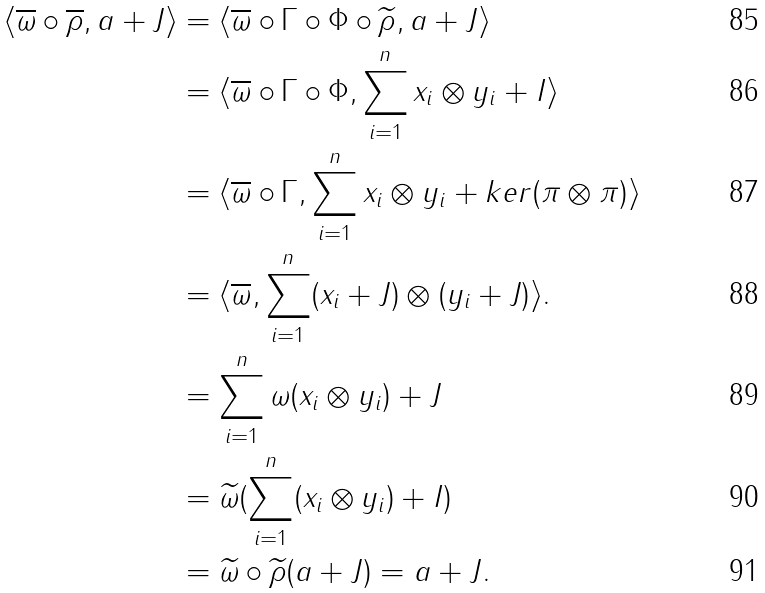Convert formula to latex. <formula><loc_0><loc_0><loc_500><loc_500>\langle \overline { \omega } \circ \overline { \rho } , a + J \rangle & = \langle \overline { \omega } \circ \Gamma \circ \Phi \circ \widetilde { \rho } , a + J \rangle \\ & = \langle \overline { \omega } \circ \Gamma \circ \Phi , \sum _ { i = 1 } ^ { n } x _ { i } \otimes y _ { i } + I \rangle \\ & = \langle \overline { \omega } \circ \Gamma , \sum _ { i = 1 } ^ { n } x _ { i } \otimes y _ { i } + k e r ( \pi \otimes \pi ) \rangle \\ & = \langle \overline { \omega } , \sum _ { i = 1 } ^ { n } ( x _ { i } + J ) \otimes ( y _ { i } + J ) \rangle . \\ & = \sum _ { i = 1 } ^ { n } \omega ( x _ { i } \otimes y _ { i } ) + J \\ & = \widetilde { \omega } ( \sum _ { i = 1 } ^ { n } ( x _ { i } \otimes y _ { i } ) + I ) \\ & = \widetilde { \omega } \circ \widetilde { \rho } ( a + J ) = a + J .</formula> 